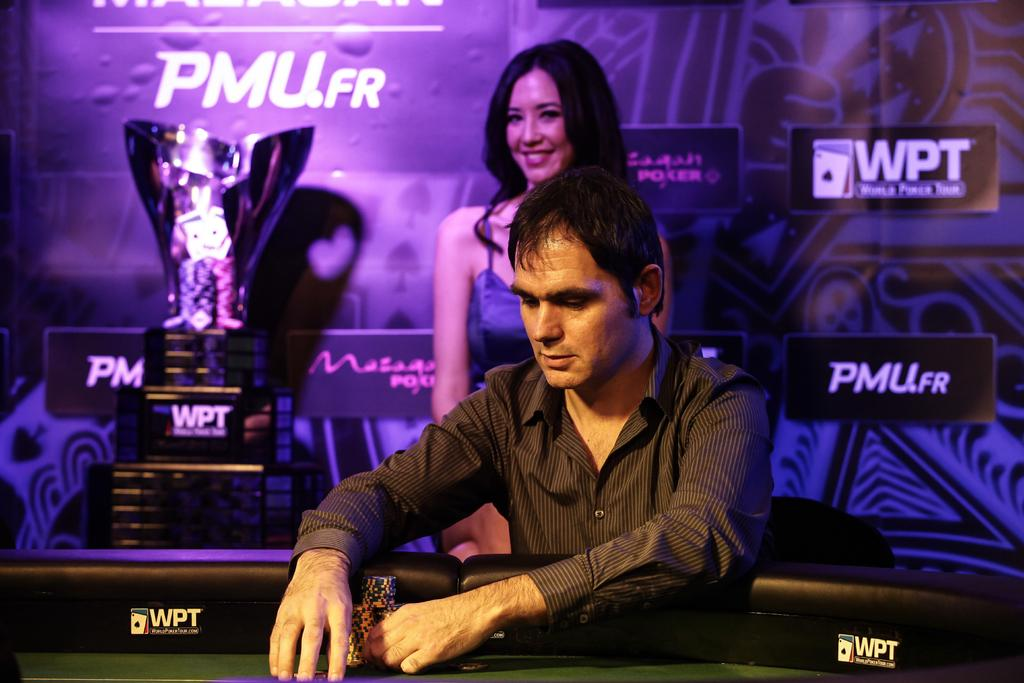<image>
Summarize the visual content of the image. a man looking down with a female behind him smiling, the advertisements in the back say PMU.FR and WPT. 